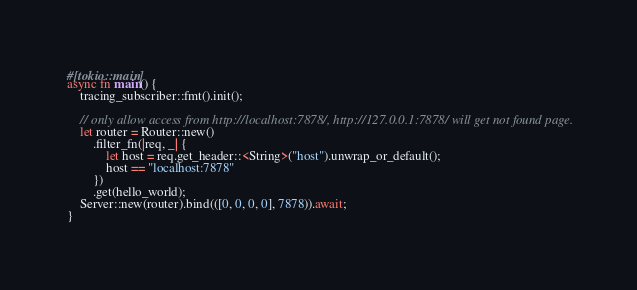<code> <loc_0><loc_0><loc_500><loc_500><_Rust_>#[tokio::main]
async fn main() {
    tracing_subscriber::fmt().init();

    // only allow access from http://localhost:7878/, http://127.0.0.1:7878/ will get not found page.
    let router = Router::new()
        .filter_fn(|req, _| {
            let host = req.get_header::<String>("host").unwrap_or_default();
            host == "localhost:7878"
        })
        .get(hello_world);
    Server::new(router).bind(([0, 0, 0, 0], 7878)).await;
}
</code> 